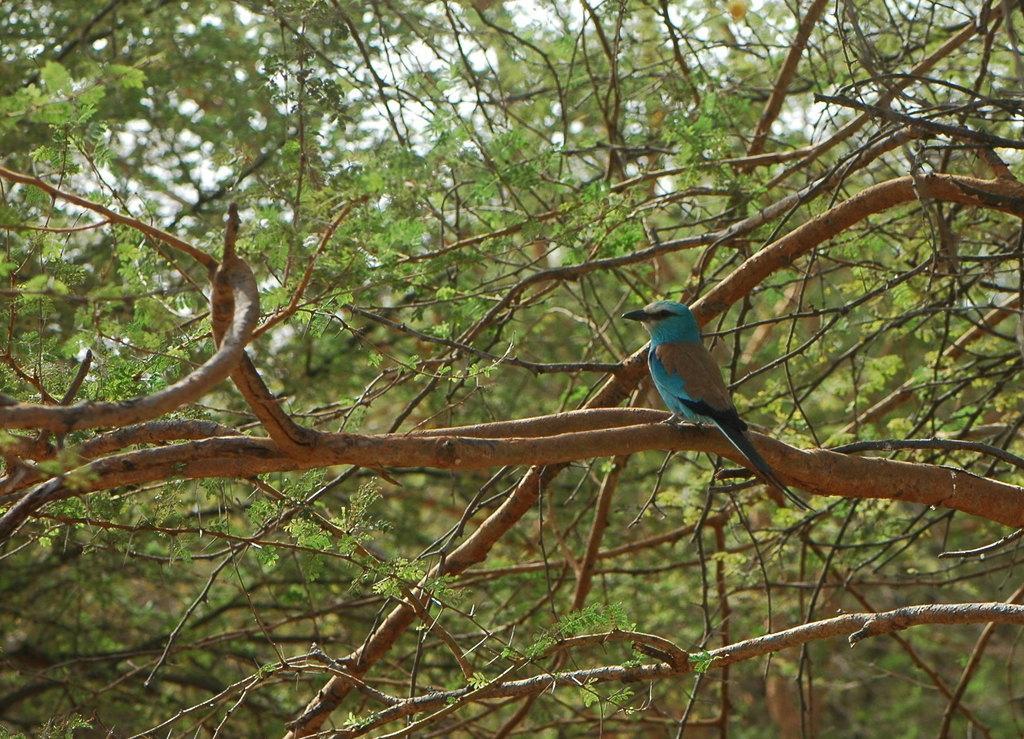Please provide a concise description of this image. In this image, I can see a bird standing on a branch. These are the trees with the branches and leaves. 